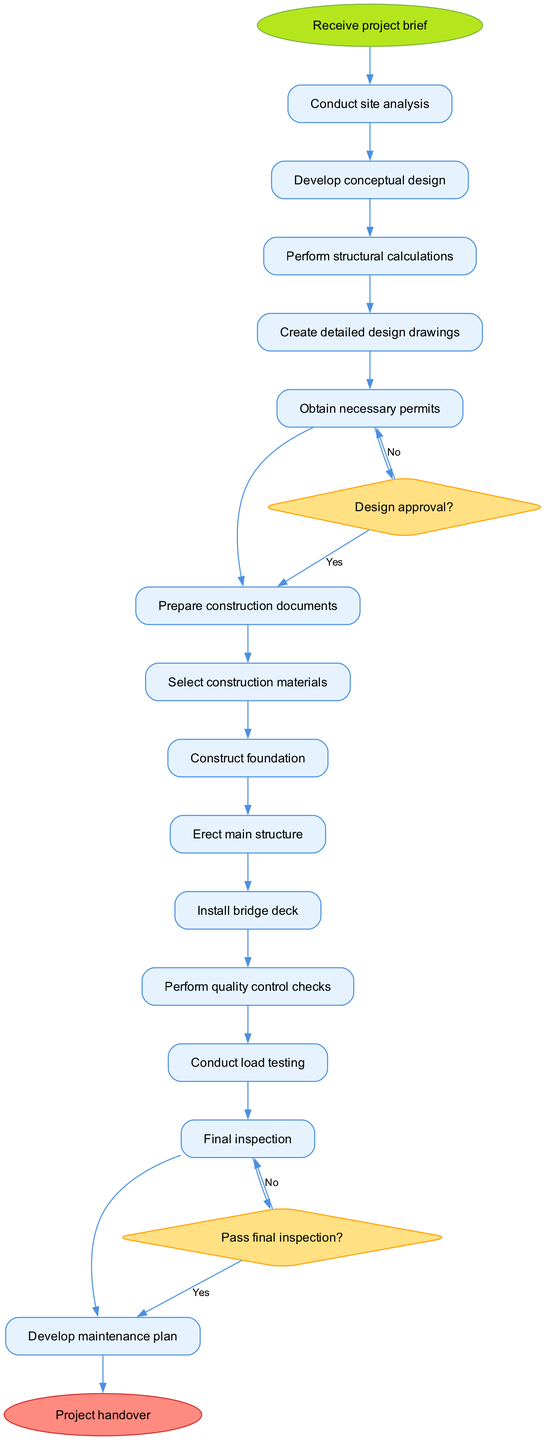What is the starting activity of the bridge construction project? The starting activity is indicated as the first node in the diagram following the initial node label. The diagram shows "Receive project brief" as the initial activity to begin the process.
Answer: Receive project brief How many decision nodes are present in the diagram? The diagram lists decision points where conditions are evaluated. Two decision nodes are explicitly stated: one for design approval and another for final inspection. Counting these gives a total of two decision nodes.
Answer: 2 What is the activity following "Conduct site analysis"? The diagram shows the flow of activities with each connected to the next. After "Conduct site analysis," the next activity is specified as "Develop conceptual design."
Answer: Develop conceptual design What happens if the design does not receive approval? The decision node corresponding to "Design approval?" indicates the flow based on this outcome. If the design is not approved, the process leads to "Revise design," thus addressing the issues raised before moving forward.
Answer: Revise design Which activity is performed right before the final inspection? The activity leading to the final inspection is "Conduct load testing." This reflects the standard sequence of checking structural integrity prior to the final assessment.
Answer: Conduct load testing If the final inspection does not pass, what activity follows? The diagram illustrates the decision point of "Pass final inspection?" Under the 'no' condition for this decision, the flow moves to "Address issues," aiming to resolve shortcomings identified during the inspection.
Answer: Address issues What is the last activity before project handover? The diagram shows that "Develop maintenance plan" occurs just before reaching the final node labeled "Project handover." This step ensures the longevity and upkeep of the bridge after completion.
Answer: Develop maintenance plan What condition must be met to proceed to "Prepare construction documents"? The path leading to "Prepare construction documents" requires a positive answer to the decision node "Design approval?" Thus, the approval condition is critical for advancing this phase of the project.
Answer: Design approval What shape is used to represent activities in the diagram? In the diagram, activities are denoted using a rectangular shape with rounded corners, which is a common convention in activity diagrams to indicate tasks or actions.
Answer: Box 